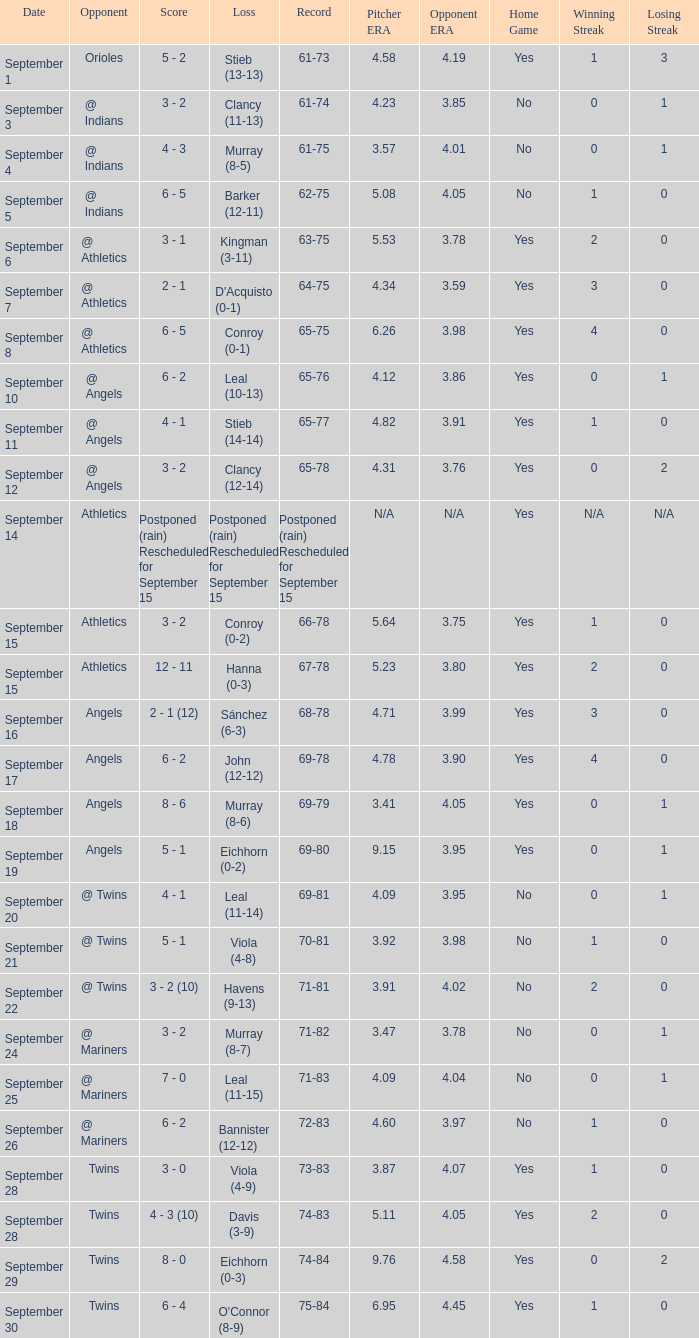Name the loss for record of 71-81 Havens (9-13). 